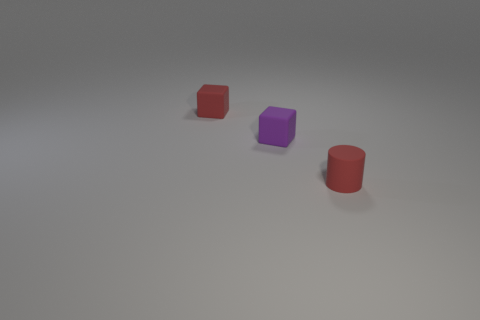Is there a small rubber thing of the same color as the cylinder?
Provide a short and direct response. Yes. Are there an equal number of red matte cylinders that are behind the tiny purple block and large purple objects?
Give a very brief answer. Yes. How many big brown metallic objects are there?
Ensure brevity in your answer.  0. There is a object that is on the right side of the red cube and behind the rubber cylinder; what shape is it?
Offer a very short reply. Cube. Is the color of the rubber cylinder in front of the small red rubber cube the same as the small matte object that is to the left of the purple rubber object?
Offer a terse response. Yes. Are there any small red things made of the same material as the tiny purple cube?
Your response must be concise. Yes. Are there an equal number of purple matte things in front of the small red cube and purple rubber things that are left of the red cylinder?
Your answer should be very brief. Yes. There is a red object to the right of the red thing on the left side of the small rubber cylinder; what number of objects are behind it?
Provide a short and direct response. 2. There is a block that is the same color as the matte cylinder; what is its material?
Your answer should be compact. Rubber. How many other purple things have the same shape as the tiny purple rubber object?
Your answer should be compact. 0. 